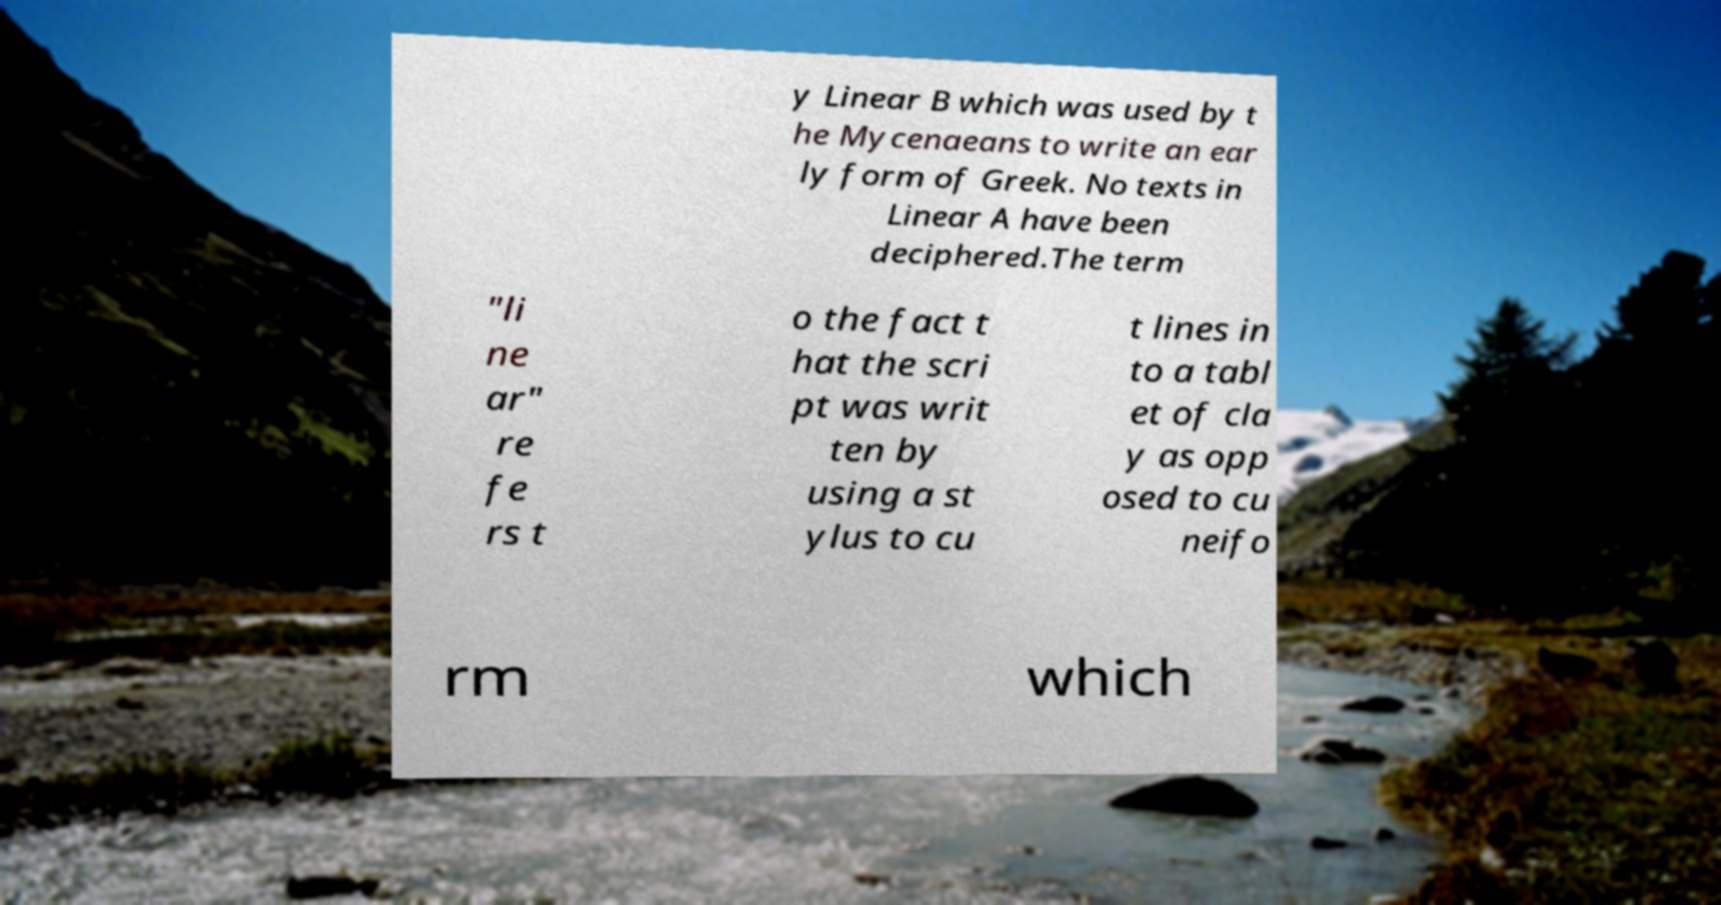For documentation purposes, I need the text within this image transcribed. Could you provide that? y Linear B which was used by t he Mycenaeans to write an ear ly form of Greek. No texts in Linear A have been deciphered.The term "li ne ar" re fe rs t o the fact t hat the scri pt was writ ten by using a st ylus to cu t lines in to a tabl et of cla y as opp osed to cu neifo rm which 